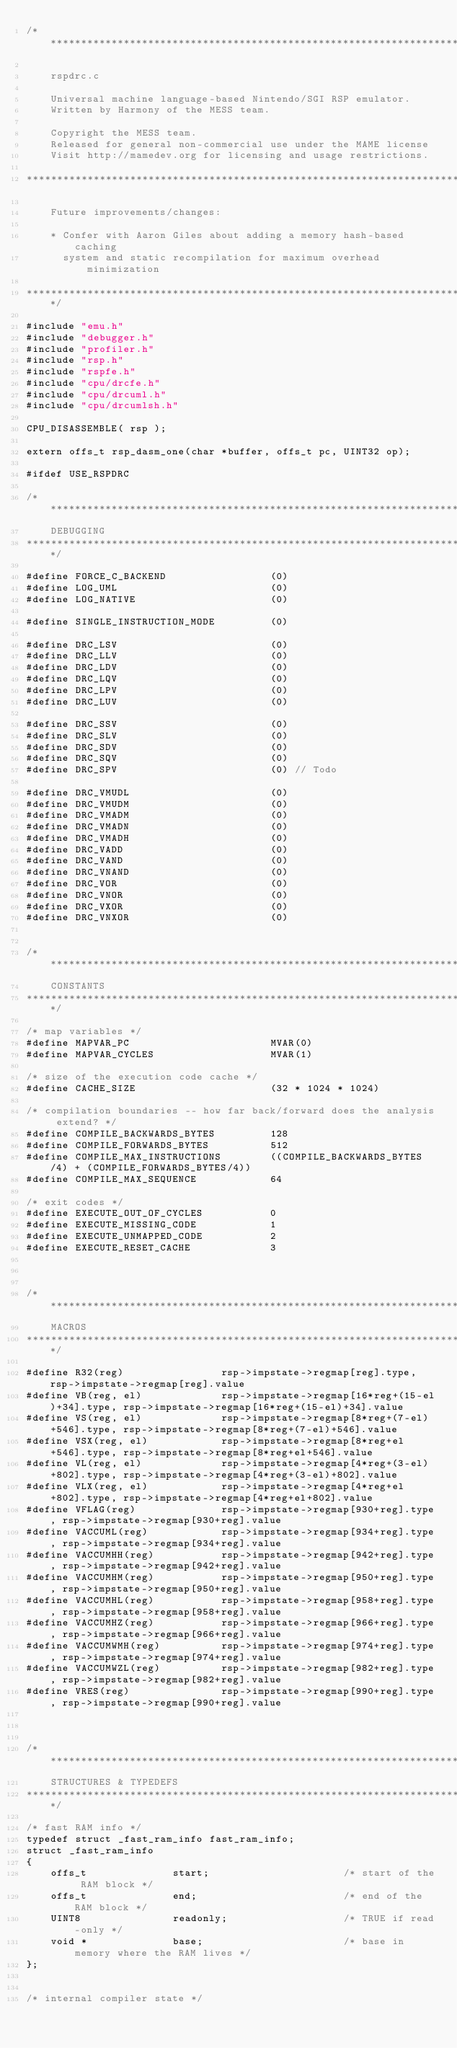<code> <loc_0><loc_0><loc_500><loc_500><_C_>/***************************************************************************

    rspdrc.c

    Universal machine language-based Nintendo/SGI RSP emulator.
    Written by Harmony of the MESS team.

    Copyright the MESS team.
    Released for general non-commercial use under the MAME license
    Visit http://mamedev.org for licensing and usage restrictions.

****************************************************************************

    Future improvements/changes:

    * Confer with Aaron Giles about adding a memory hash-based caching
      system and static recompilation for maximum overhead minimization

***************************************************************************/

#include "emu.h"
#include "debugger.h"
#include "profiler.h"
#include "rsp.h"
#include "rspfe.h"
#include "cpu/drcfe.h"
#include "cpu/drcuml.h"
#include "cpu/drcumlsh.h"

CPU_DISASSEMBLE( rsp );

extern offs_t rsp_dasm_one(char *buffer, offs_t pc, UINT32 op);

#ifdef USE_RSPDRC

/***************************************************************************
    DEBUGGING
***************************************************************************/

#define FORCE_C_BACKEND					(0)
#define LOG_UML							(0)
#define LOG_NATIVE						(0)

#define SINGLE_INSTRUCTION_MODE			(0)

#define DRC_LSV							(0)
#define DRC_LLV							(0)
#define DRC_LDV							(0)
#define DRC_LQV							(0)
#define DRC_LPV							(0)
#define DRC_LUV							(0)

#define DRC_SSV							(0)
#define DRC_SLV							(0)
#define DRC_SDV							(0)
#define DRC_SQV							(0)
#define DRC_SPV							(0) // Todo

#define DRC_VMUDL						(0)
#define DRC_VMUDM						(0)
#define DRC_VMADM						(0)
#define DRC_VMADN						(0)
#define DRC_VMADH						(0)
#define DRC_VADD						(0)
#define DRC_VAND						(0)
#define DRC_VNAND						(0)
#define DRC_VOR							(0)
#define DRC_VNOR						(0)
#define DRC_VXOR						(0)
#define DRC_VNXOR						(0)


/***************************************************************************
    CONSTANTS
***************************************************************************/

/* map variables */
#define MAPVAR_PC						MVAR(0)
#define MAPVAR_CYCLES					MVAR(1)

/* size of the execution code cache */
#define CACHE_SIZE						(32 * 1024 * 1024)

/* compilation boundaries -- how far back/forward does the analysis extend? */
#define COMPILE_BACKWARDS_BYTES			128
#define COMPILE_FORWARDS_BYTES			512
#define COMPILE_MAX_INSTRUCTIONS		((COMPILE_BACKWARDS_BYTES/4) + (COMPILE_FORWARDS_BYTES/4))
#define COMPILE_MAX_SEQUENCE			64

/* exit codes */
#define EXECUTE_OUT_OF_CYCLES			0
#define EXECUTE_MISSING_CODE			1
#define EXECUTE_UNMAPPED_CODE			2
#define EXECUTE_RESET_CACHE				3



/***************************************************************************
    MACROS
***************************************************************************/

#define R32(reg)				rsp->impstate->regmap[reg].type, rsp->impstate->regmap[reg].value
#define VB(reg, el)				rsp->impstate->regmap[16*reg+(15-el)+34].type, rsp->impstate->regmap[16*reg+(15-el)+34].value
#define VS(reg, el)				rsp->impstate->regmap[8*reg+(7-el)+546].type, rsp->impstate->regmap[8*reg+(7-el)+546].value
#define VSX(reg, el)			rsp->impstate->regmap[8*reg+el+546].type, rsp->impstate->regmap[8*reg+el+546].value
#define VL(reg, el)				rsp->impstate->regmap[4*reg+(3-el)+802].type, rsp->impstate->regmap[4*reg+(3-el)+802].value
#define VLX(reg, el)			rsp->impstate->regmap[4*reg+el+802].type, rsp->impstate->regmap[4*reg+el+802].value
#define VFLAG(reg)				rsp->impstate->regmap[930+reg].type, rsp->impstate->regmap[930+reg].value
#define VACCUML(reg)			rsp->impstate->regmap[934+reg].type, rsp->impstate->regmap[934+reg].value
#define VACCUMHH(reg)			rsp->impstate->regmap[942+reg].type, rsp->impstate->regmap[942+reg].value
#define VACCUMHM(reg)			rsp->impstate->regmap[950+reg].type, rsp->impstate->regmap[950+reg].value
#define VACCUMHL(reg)			rsp->impstate->regmap[958+reg].type, rsp->impstate->regmap[958+reg].value
#define VACCUMHZ(reg)			rsp->impstate->regmap[966+reg].type, rsp->impstate->regmap[966+reg].value
#define VACCUMWMH(reg)			rsp->impstate->regmap[974+reg].type, rsp->impstate->regmap[974+reg].value
#define VACCUMWZL(reg)			rsp->impstate->regmap[982+reg].type, rsp->impstate->regmap[982+reg].value
#define VRES(reg)				rsp->impstate->regmap[990+reg].type, rsp->impstate->regmap[990+reg].value



/***************************************************************************
    STRUCTURES & TYPEDEFS
***************************************************************************/

/* fast RAM info */
typedef struct _fast_ram_info fast_ram_info;
struct _fast_ram_info
{
	offs_t				start;						/* start of the RAM block */
	offs_t				end;						/* end of the RAM block */
	UINT8				readonly;					/* TRUE if read-only */
	void *				base;						/* base in memory where the RAM lives */
};


/* internal compiler state */</code> 